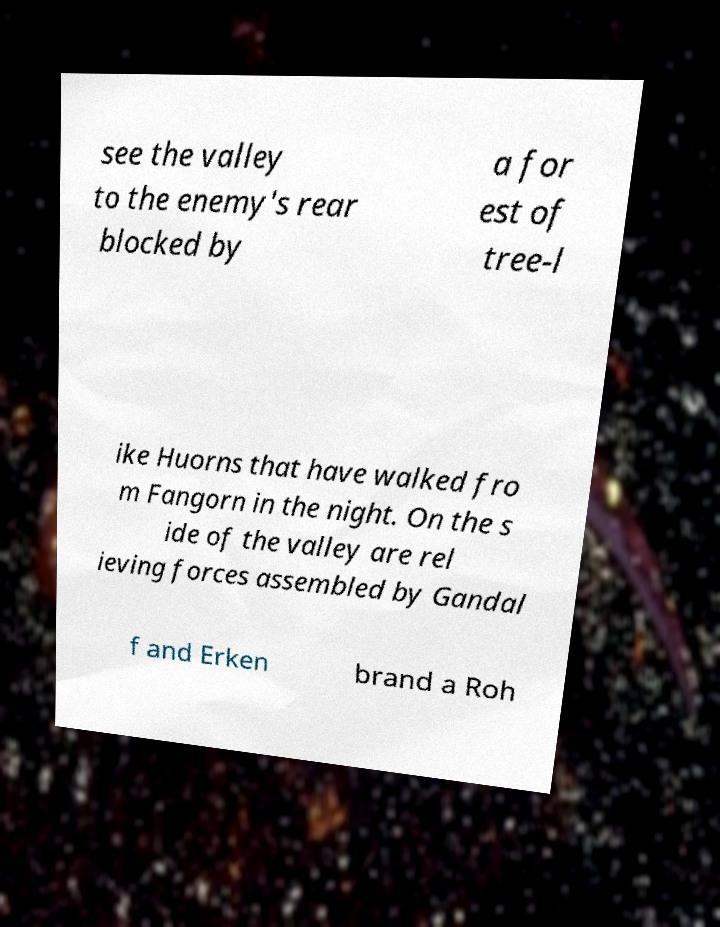There's text embedded in this image that I need extracted. Can you transcribe it verbatim? see the valley to the enemy's rear blocked by a for est of tree-l ike Huorns that have walked fro m Fangorn in the night. On the s ide of the valley are rel ieving forces assembled by Gandal f and Erken brand a Roh 